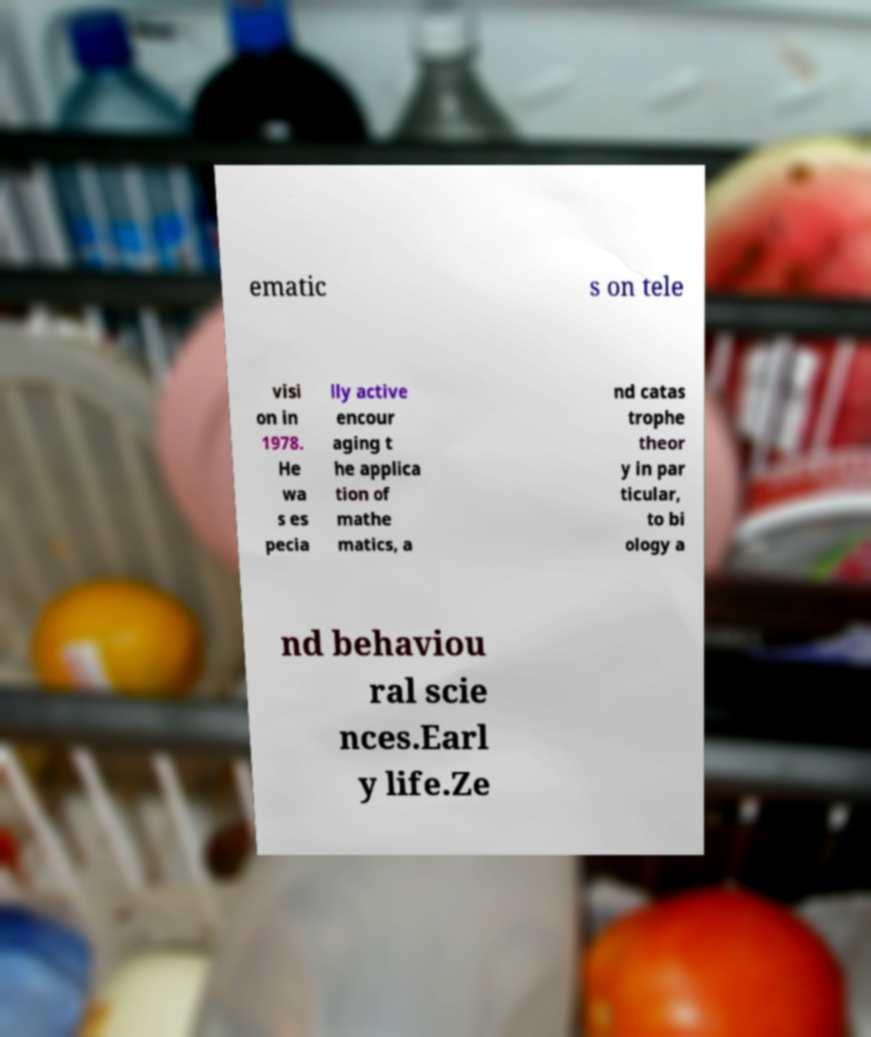Can you read and provide the text displayed in the image?This photo seems to have some interesting text. Can you extract and type it out for me? ematic s on tele visi on in 1978. He wa s es pecia lly active encour aging t he applica tion of mathe matics, a nd catas trophe theor y in par ticular, to bi ology a nd behaviou ral scie nces.Earl y life.Ze 